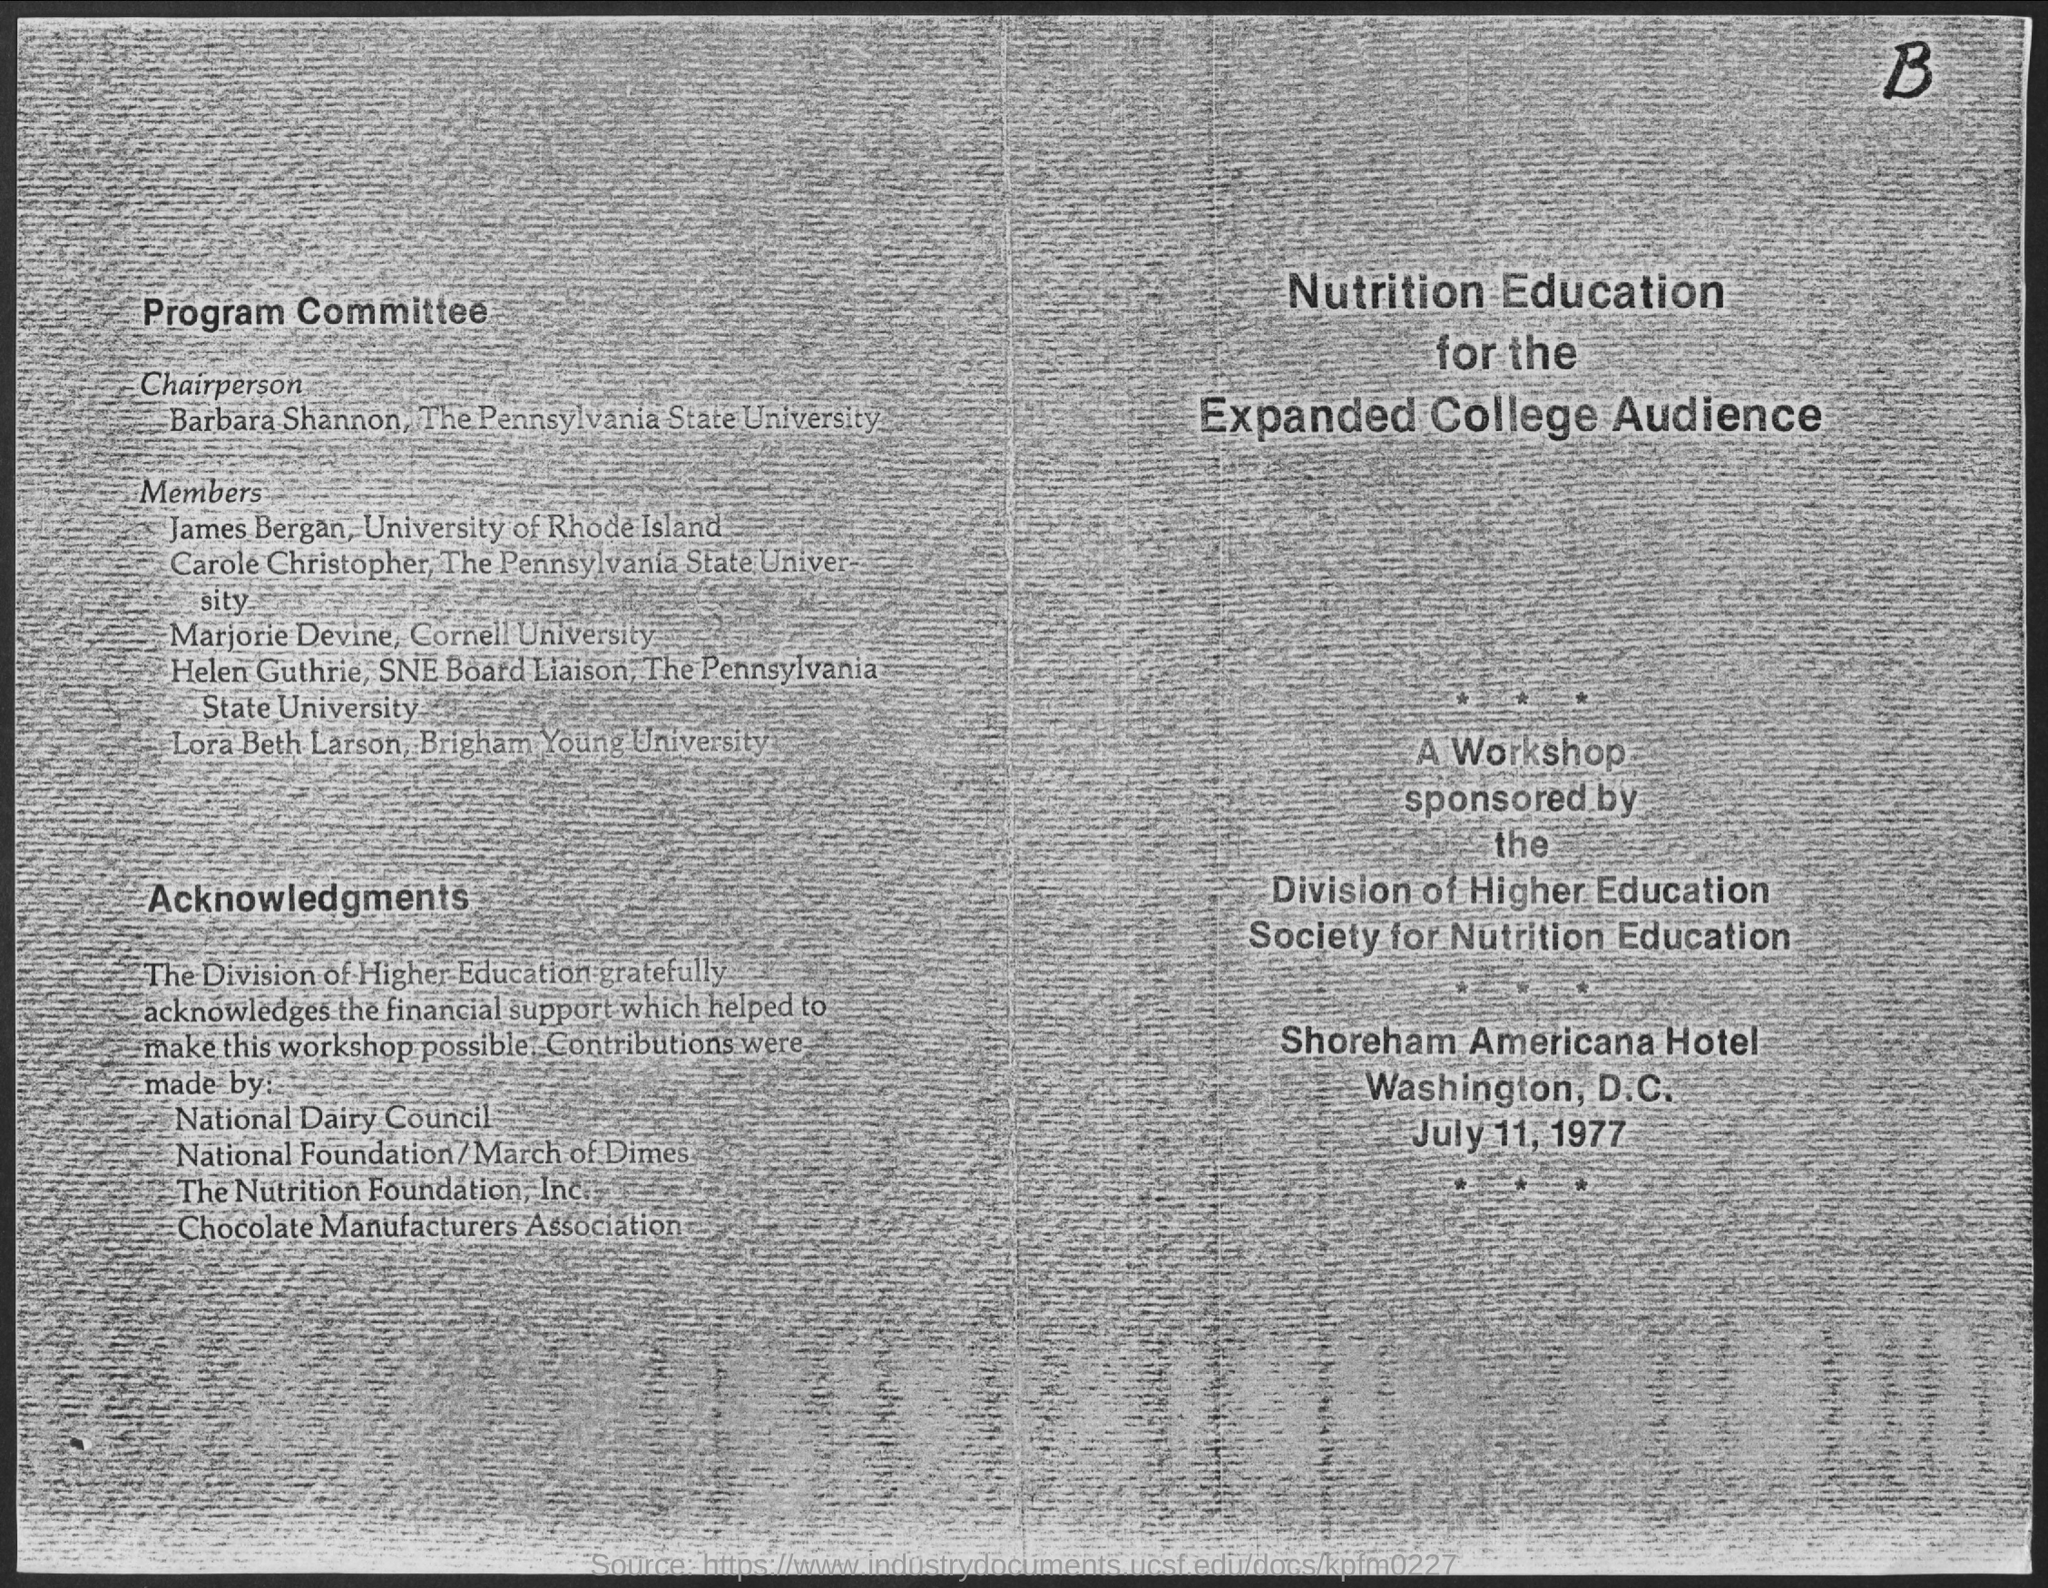Who is the Chairperson of Program Committee?
Keep it short and to the point. Barbara shannon. Lora Beth Larson is from which university?
Make the answer very short. Brigham young university. On what date is the workshop?
Provide a short and direct response. July 11,1977. What is the main title of the document?
Offer a terse response. Nutrition Education for the Expanded College Audience. 